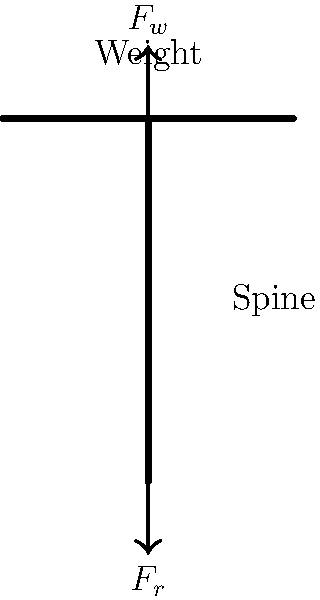When performing a deadlift, what is the primary force acting on the spine, and how does it relate to the weight being lifted? To understand the forces acting on the spine during a deadlift, we need to consider the following steps:

1. Identify the forces:
   - $F_w$: The downward force due to the weight being lifted
   - $F_r$: The reactive force from the ground through the body

2. Apply Newton's Third Law:
   The reactive force $F_r$ is equal and opposite to the weight force $F_w$.

3. Force transmission:
   The spine acts as a column, transmitting the force from the weight to the lower body.

4. Compressive force:
   The primary force acting on the spine is a compressive force, which is equal to the weight being lifted.

5. Magnitude relation:
   The compressive force on the spine is directly proportional to the weight being lifted.

6. Safety considerations:
   Proper form is crucial to distribute the force evenly along the spine and engage supporting muscles to minimize injury risk.

In the context of the keto diet, it's important to note that maintaining proper form during exercises like deadlifts is crucial, regardless of the dietary approach. The keto diet may impact energy levels and muscle glycogen, which could affect lifting performance, but it doesn't change the fundamental biomechanics of the exercise.
Answer: Compressive force equal to the weight lifted 